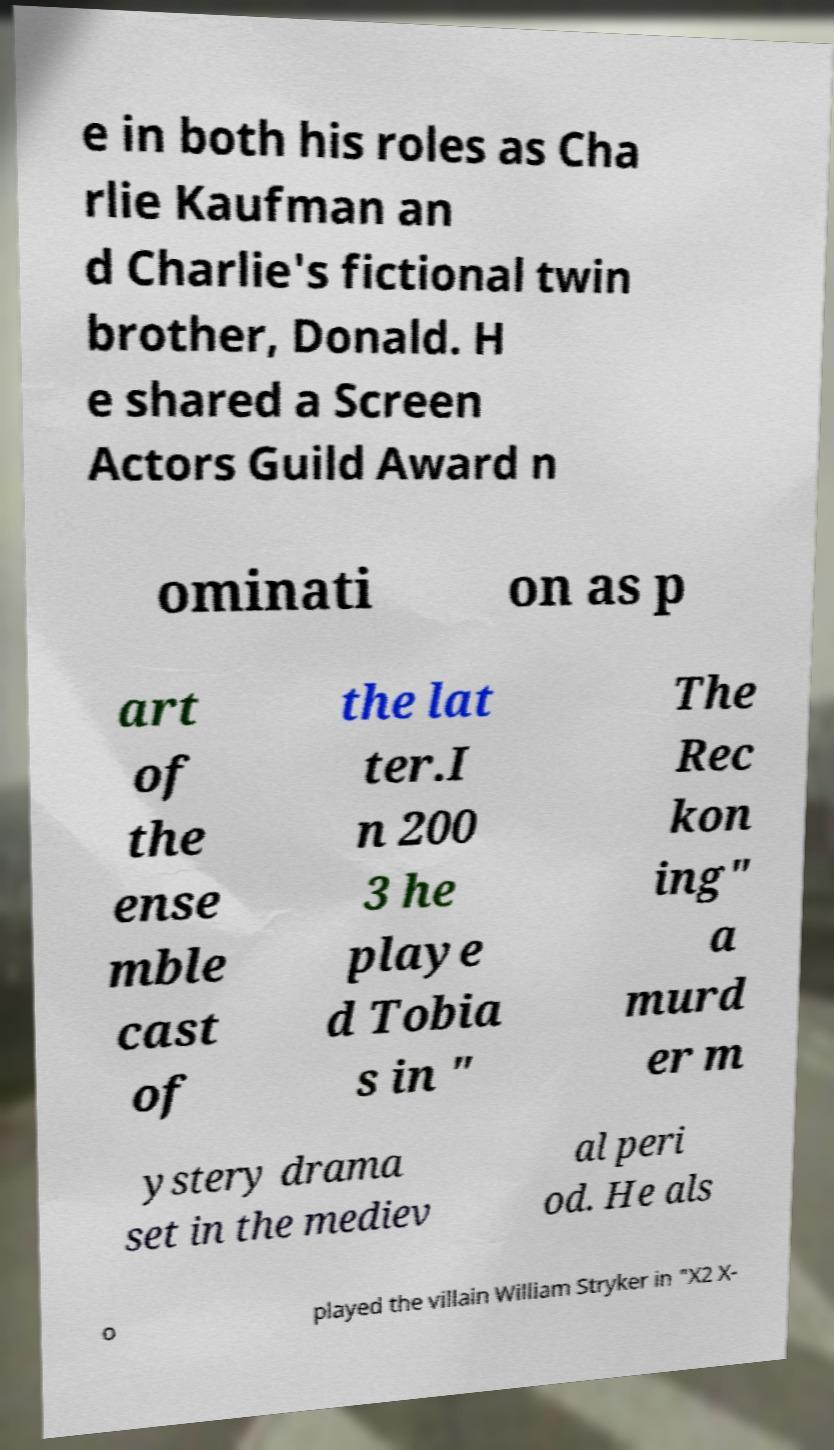I need the written content from this picture converted into text. Can you do that? e in both his roles as Cha rlie Kaufman an d Charlie's fictional twin brother, Donald. H e shared a Screen Actors Guild Award n ominati on as p art of the ense mble cast of the lat ter.I n 200 3 he playe d Tobia s in " The Rec kon ing" a murd er m ystery drama set in the mediev al peri od. He als o played the villain William Stryker in "X2 X- 